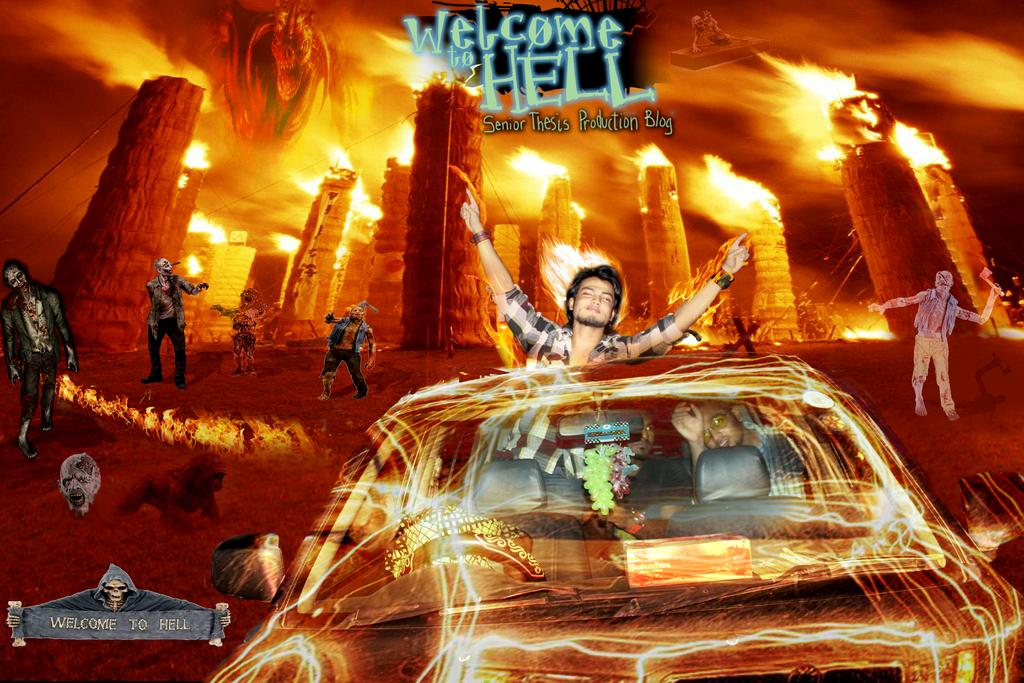<image>
Describe the image concisely. Welcome to Hell poster with a guy and girl sitting in a car 